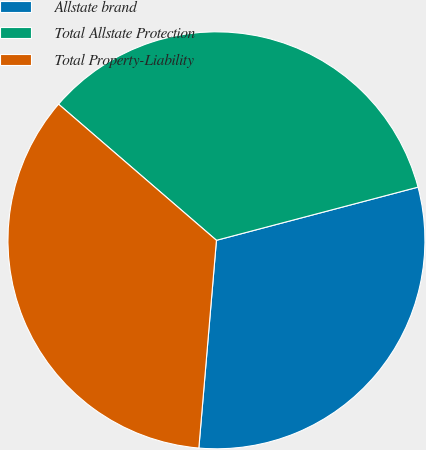<chart> <loc_0><loc_0><loc_500><loc_500><pie_chart><fcel>Allstate brand<fcel>Total Allstate Protection<fcel>Total Property-Liability<nl><fcel>30.45%<fcel>34.57%<fcel>34.98%<nl></chart> 